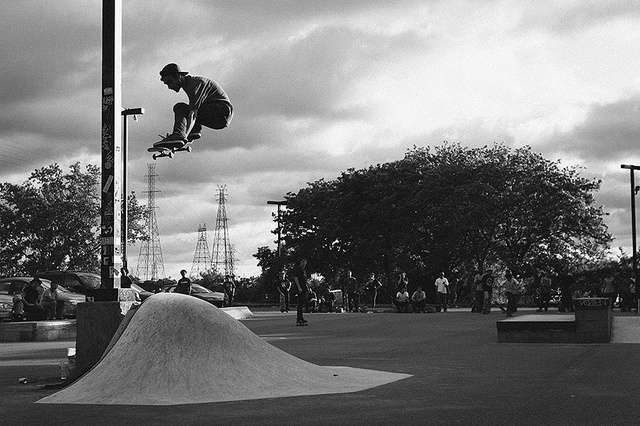Describe the objects in this image and their specific colors. I can see people in darkgray, black, gray, and lightgray tones, people in darkgray, black, gray, and lightgray tones, car in darkgray, black, gray, and lightgray tones, car in darkgray, black, gray, and lightgray tones, and people in darkgray, black, gray, and white tones in this image. 